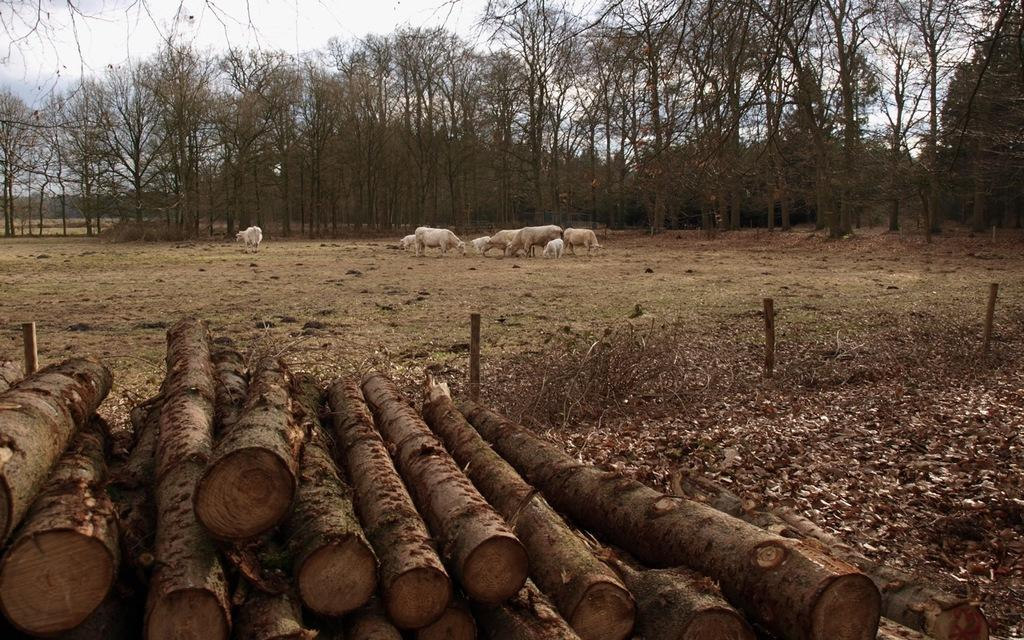What type of objects can be seen in the image? There are wooden logs and poles in the image. What can be seen in the background of the image? There are animals, trees, and the sky visible in the background of the image. Where is the basket located in the image? There is no basket present in the image. Can you tell me how many basketballs are visible in the image? There are no basketballs present in the image. 